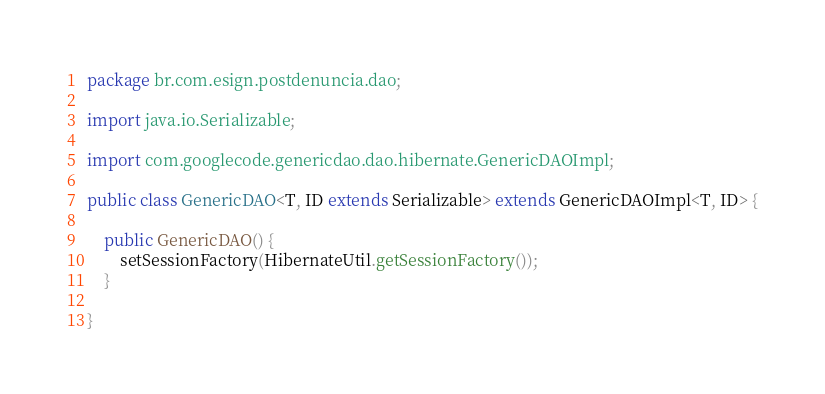<code> <loc_0><loc_0><loc_500><loc_500><_Java_>package br.com.esign.postdenuncia.dao;

import java.io.Serializable;

import com.googlecode.genericdao.dao.hibernate.GenericDAOImpl;

public class GenericDAO<T, ID extends Serializable> extends GenericDAOImpl<T, ID> {

    public GenericDAO() {
        setSessionFactory(HibernateUtil.getSessionFactory());
    }

}</code> 